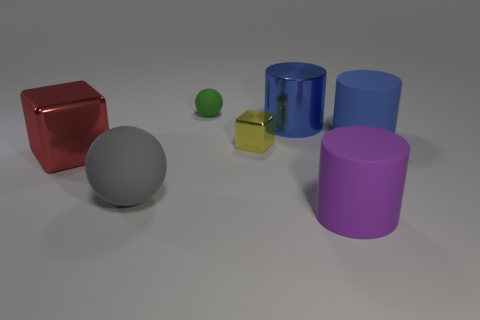Are there any yellow blocks that have the same material as the red thing?
Make the answer very short. Yes. Is the thing behind the blue shiny cylinder made of the same material as the big object that is right of the purple rubber thing?
Provide a succinct answer. Yes. Are there an equal number of large red things that are behind the big blue shiny object and gray balls that are right of the blue matte object?
Your answer should be compact. Yes. What is the color of the metal cylinder that is the same size as the gray rubber sphere?
Keep it short and to the point. Blue. Are there any large objects of the same color as the big metallic cylinder?
Provide a short and direct response. Yes. How many things are rubber objects to the right of the small ball or big yellow cylinders?
Your response must be concise. 2. What number of other things are there of the same size as the red shiny thing?
Your response must be concise. 4. There is a purple cylinder that is in front of the rubber thing that is behind the large rubber thing that is behind the large gray ball; what is its material?
Keep it short and to the point. Rubber. How many blocks are either cyan shiny things or big blue rubber things?
Make the answer very short. 0. Are there more large objects to the right of the big purple cylinder than small matte spheres that are on the left side of the green object?
Your answer should be compact. Yes. 